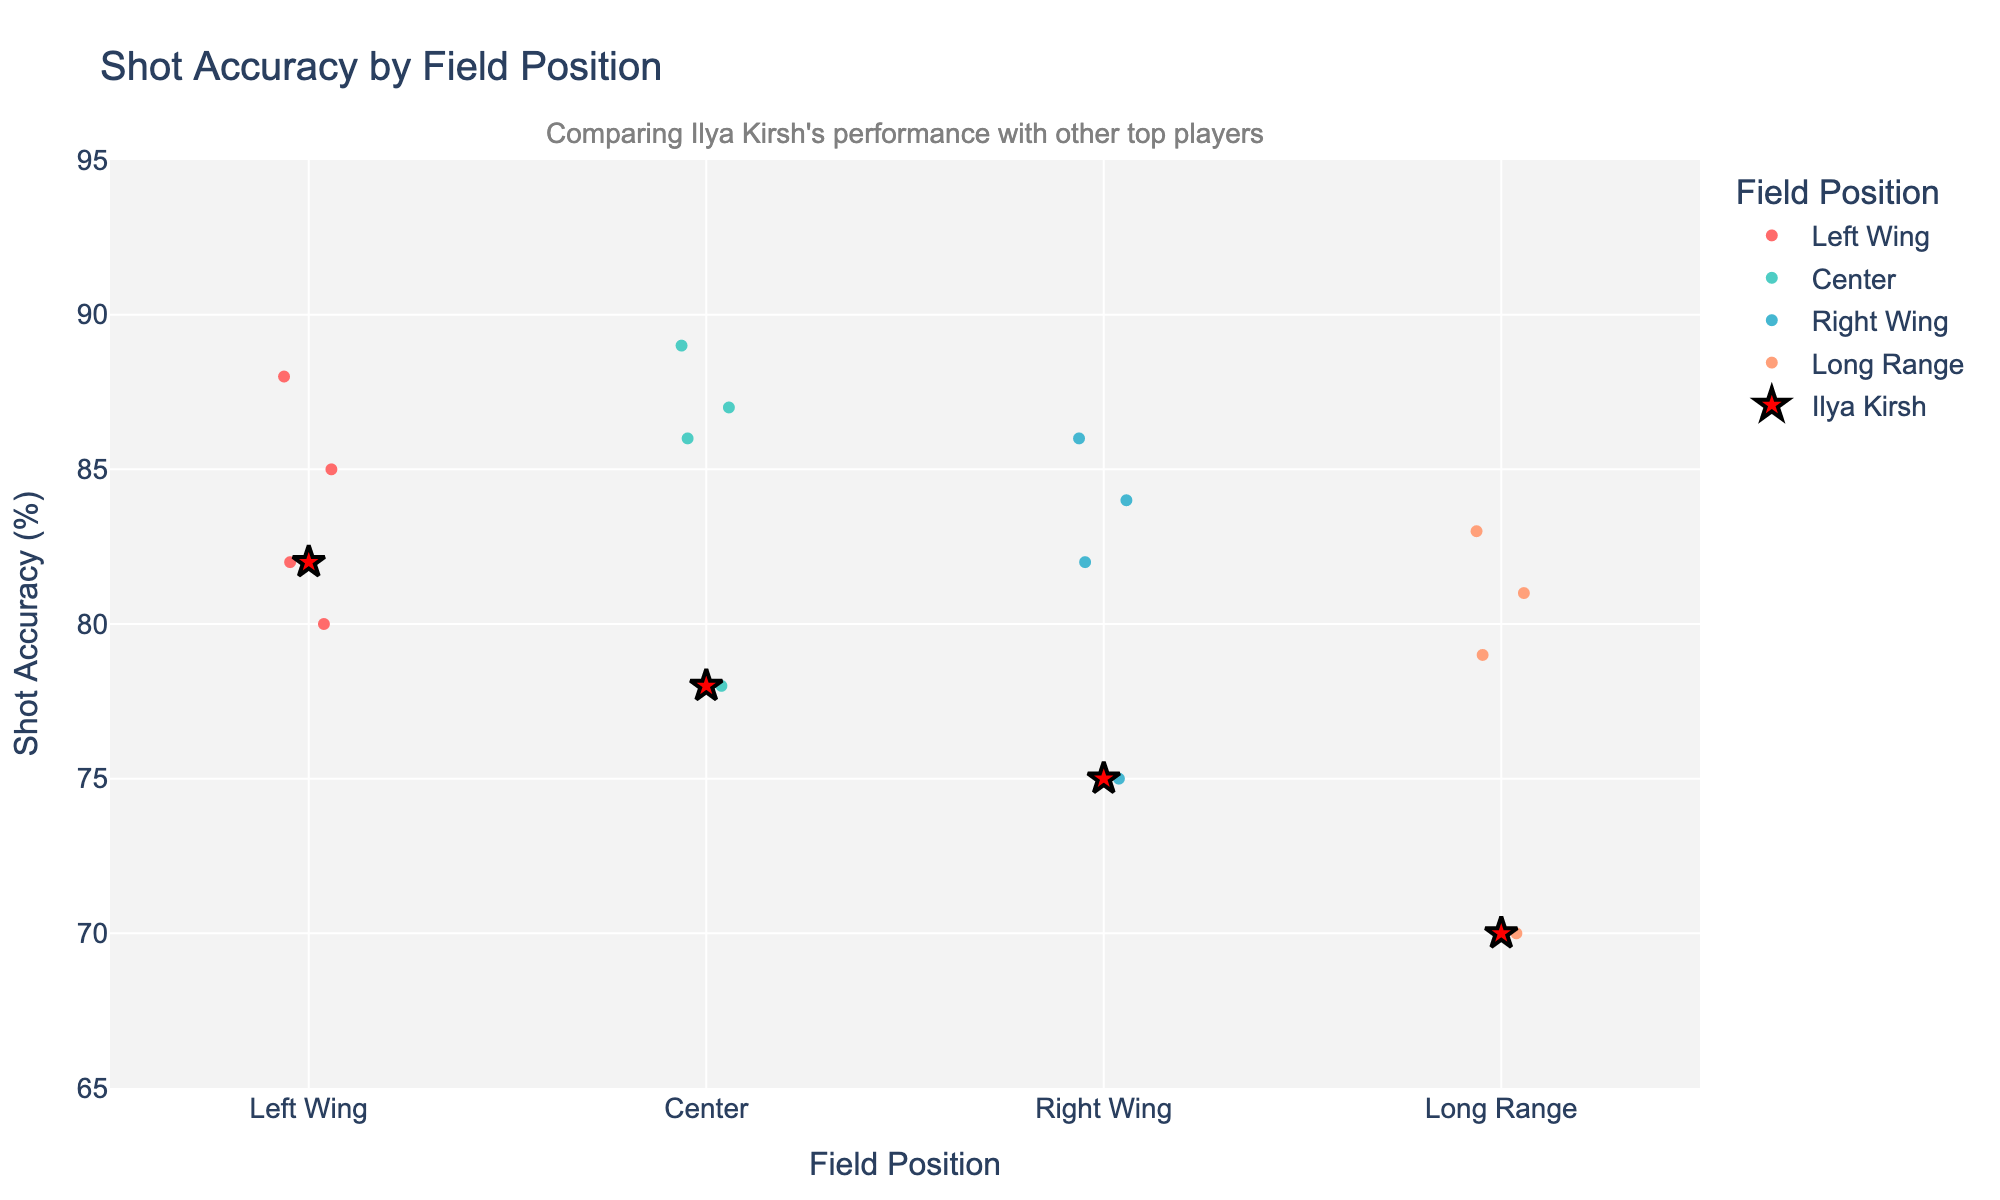What is the title of the plot? The title of the plot is located at the top and provides an overview of the chart's content. The plot's title is "Shot Accuracy by Field Position."
Answer: Shot Accuracy by Field Position How many field positions are compared in the plot? The plot's x-axis categories represent the different field positions. By counting these categories, we can see there are four positions: Left Wing, Center, Right Wing, and Long Range.
Answer: 4 Which field position has the highest shot accuracy for Ilya Kirsh? On the plot, we highlight Ilya Kirsh's data points in red. By observing the y-axis values for these points, we see that his highest accuracy is at the Left Wing position with 82%.
Answer: Left Wing What is the difference in shot accuracy between Ilya Kirsh and the top player at the Center position? The plot shows that Ilya Kirsh has an accuracy of 78% at the Center, and the highest accuracy at this position is Cristiano Ronaldo with 89%. The difference is 89% - 78% = 11%.
Answer: 11% Who has the highest shot accuracy at the Right Wing, and what is their accuracy? Looking at the Right Wing data points, we identify the player with the highest accuracy by observing the highest y-axis value within this category, which is Mohamed Salah with an accuracy of 86%.
Answer: Mohamed Salah, 86% Compare Ilya Kirsh's shot accuracy at the Left Wing and Long Range positions. Which is higher, and by how much? Examining the red data points, Ilya Kirsh's accuracy is 82% at the Left Wing and 70% at Long Range. By subtracting these values, 82% - 70% = 12%, we see that the Left Wing accuracy is higher by 12%.
Answer: Left Wing, 12% What is the median shot accuracy for players at the Left Wing position? The accuracies at Left Wing are 88 (Lionel Messi), 85 (Neymar), 82 (Ilya Kirsh), and 80 (Eden Hazard). Arranging them in order: 80, 82, 85, 88, the median is the average of the two middle values: (82 + 85)/2 = 83.5%.
Answer: 83.5% Is Ilya Kirsh's shot accuracy below the median accuracy at the Right Wing position? The accuracies at Right Wing are 86 (Mohamed Salah), 84 (Kylian Mbappé), 82 (Gareth Bale), and 75 (Ilya Kirsh). Arranging them in ascending order: 75, 82, 84, 86, we find the median is (82 + 84)/2 = 83%. Ilya Kirsh's accuracy is 75%, which is below this median.
Answer: Yes How does Ilya Kirsh's performance compare to other top players at Long Range? Provide the statistical comparison. The accuracies at Long Range are 83 (Kevin De Bruyne), 81 (Toni Kroos), 79 (Paul Pogba), and 70 (Ilya Kirsh). Ilya Kirsh's accuracy is the lowest at 70%. Comparing it with the others, he is 13% below Kevin De Bruyne, 11% below Toni Kroos, and 9% below Paul Pogba.
Answer: Lowest, 70% 